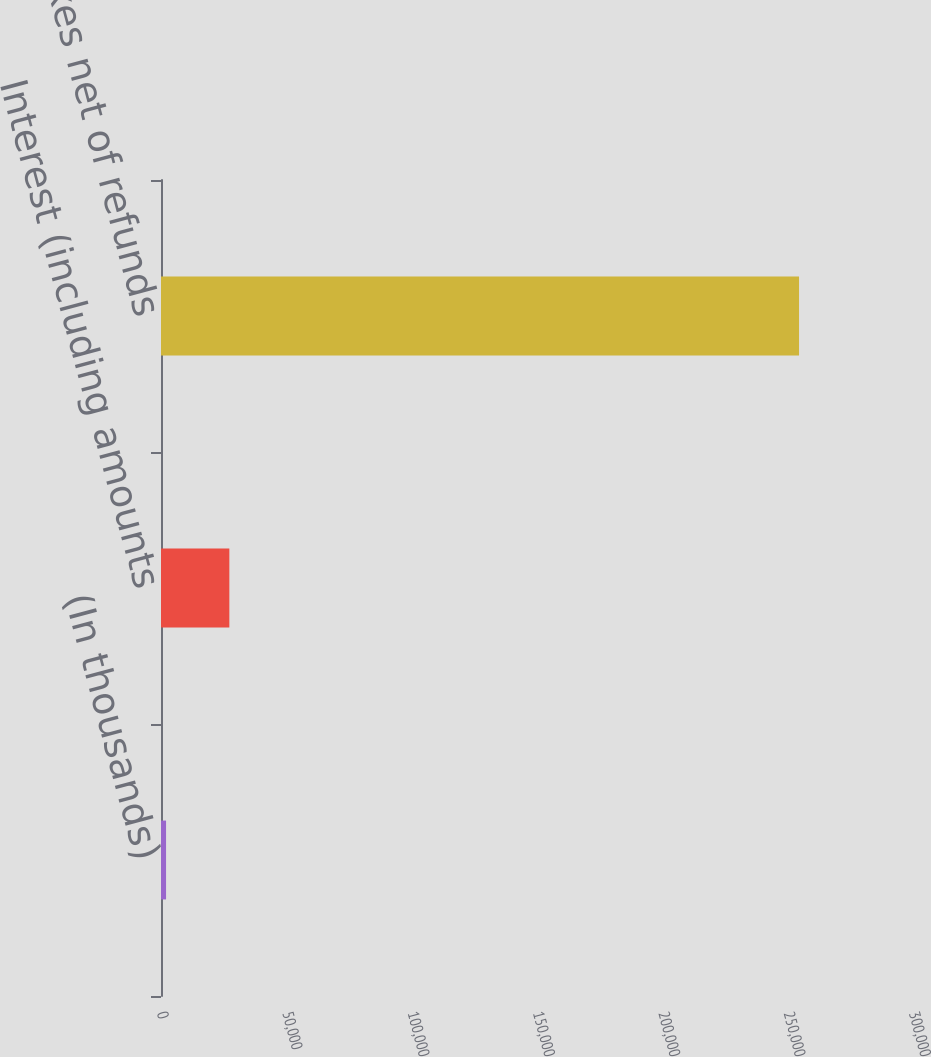<chart> <loc_0><loc_0><loc_500><loc_500><bar_chart><fcel>(In thousands)<fcel>Interest (including amounts<fcel>Income taxes net of refunds<nl><fcel>2016<fcel>27268.3<fcel>254539<nl></chart> 